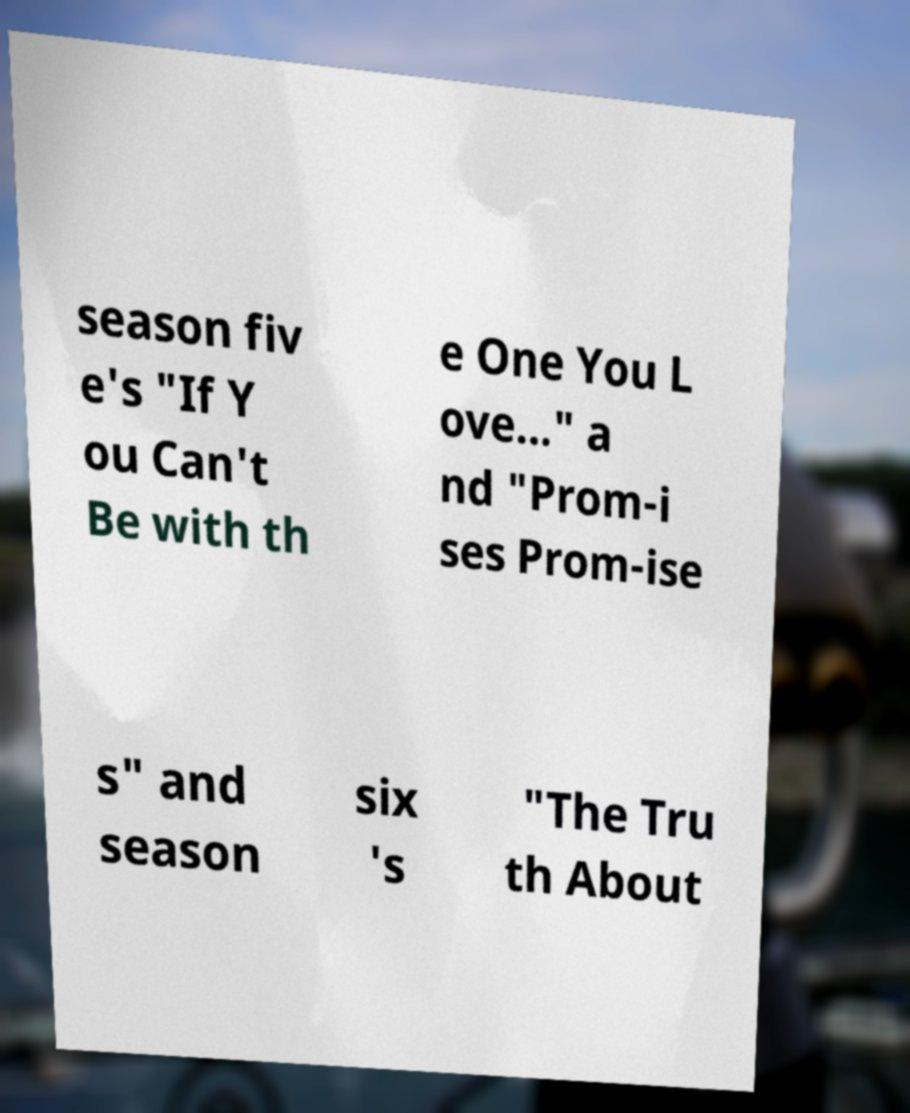Could you extract and type out the text from this image? season fiv e's "If Y ou Can't Be with th e One You L ove..." a nd "Prom-i ses Prom-ise s" and season six 's "The Tru th About 